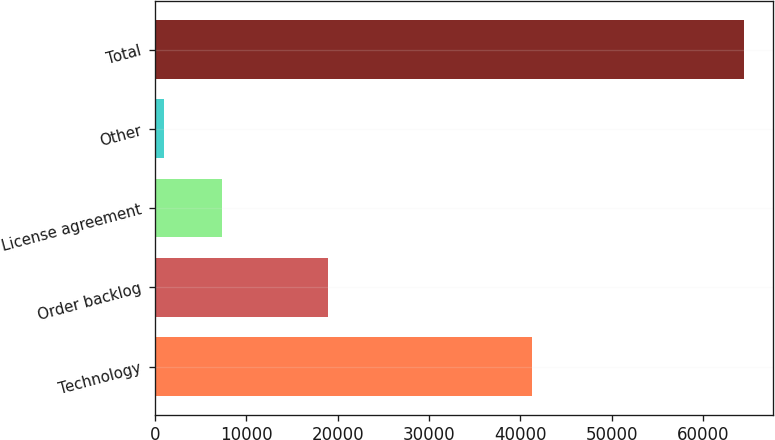Convert chart to OTSL. <chart><loc_0><loc_0><loc_500><loc_500><bar_chart><fcel>Technology<fcel>Order backlog<fcel>License agreement<fcel>Other<fcel>Total<nl><fcel>41276<fcel>18914<fcel>7316.2<fcel>970<fcel>64432<nl></chart> 